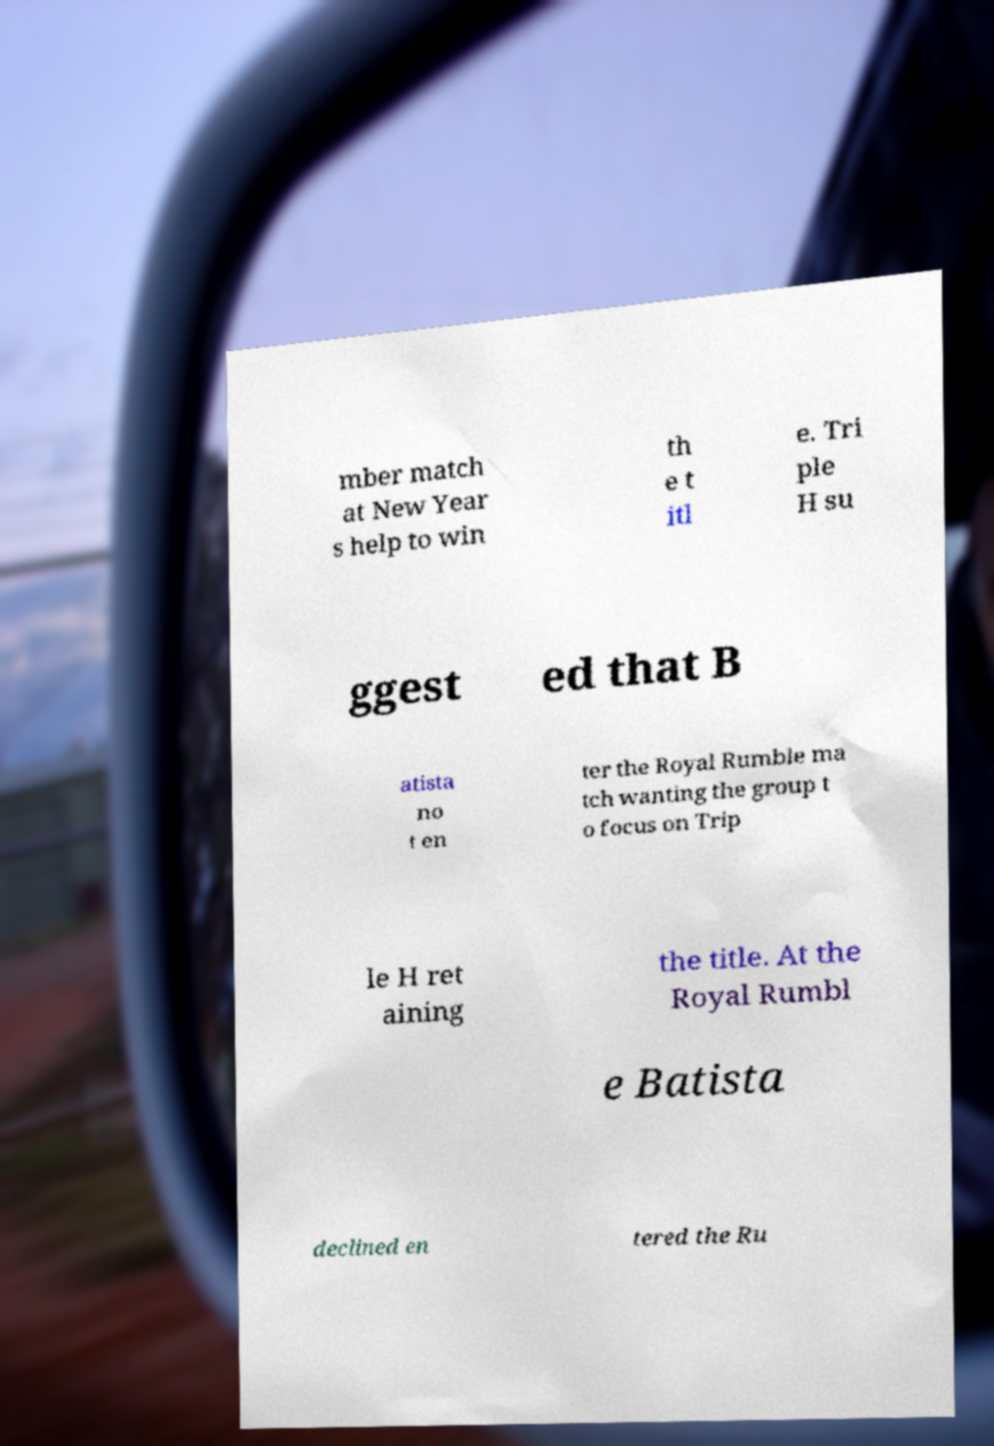There's text embedded in this image that I need extracted. Can you transcribe it verbatim? mber match at New Year s help to win th e t itl e. Tri ple H su ggest ed that B atista no t en ter the Royal Rumble ma tch wanting the group t o focus on Trip le H ret aining the title. At the Royal Rumbl e Batista declined en tered the Ru 